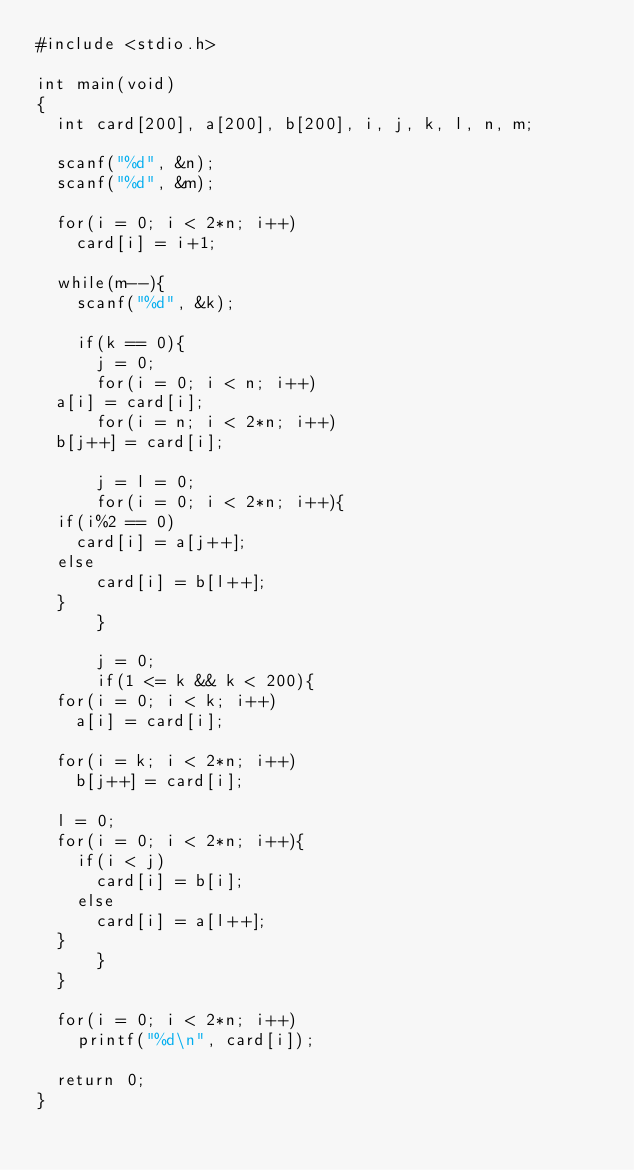Convert code to text. <code><loc_0><loc_0><loc_500><loc_500><_C_>#include <stdio.h>

int main(void)
{
  int card[200], a[200], b[200], i, j, k, l, n, m;

  scanf("%d", &n);
  scanf("%d", &m);

  for(i = 0; i < 2*n; i++)
    card[i] = i+1;

  while(m--){
    scanf("%d", &k);

    if(k == 0){
      j = 0;
      for(i = 0; i < n; i++)
	a[i] = card[i];
      for(i = n; i < 2*n; i++)
	b[j++] = card[i];

      j = l = 0;
      for(i = 0; i < 2*n; i++){
	if(i%2 == 0)
	  card[i] = a[j++];
	else
	    card[i] = b[l++];
	}
      }

      j = 0;
      if(1 <= k && k < 200){
	for(i = 0; i < k; i++)
	  a[i] = card[i];

	for(i = k; i < 2*n; i++)
	  b[j++] = card[i];
      
	l = 0;
	for(i = 0; i < 2*n; i++){
	  if(i < j)
	    card[i] = b[i];
	  else
	    card[i] = a[l++];
	}
      }
  }
    
  for(i = 0; i < 2*n; i++)
    printf("%d\n", card[i]);

  return 0;
}</code> 